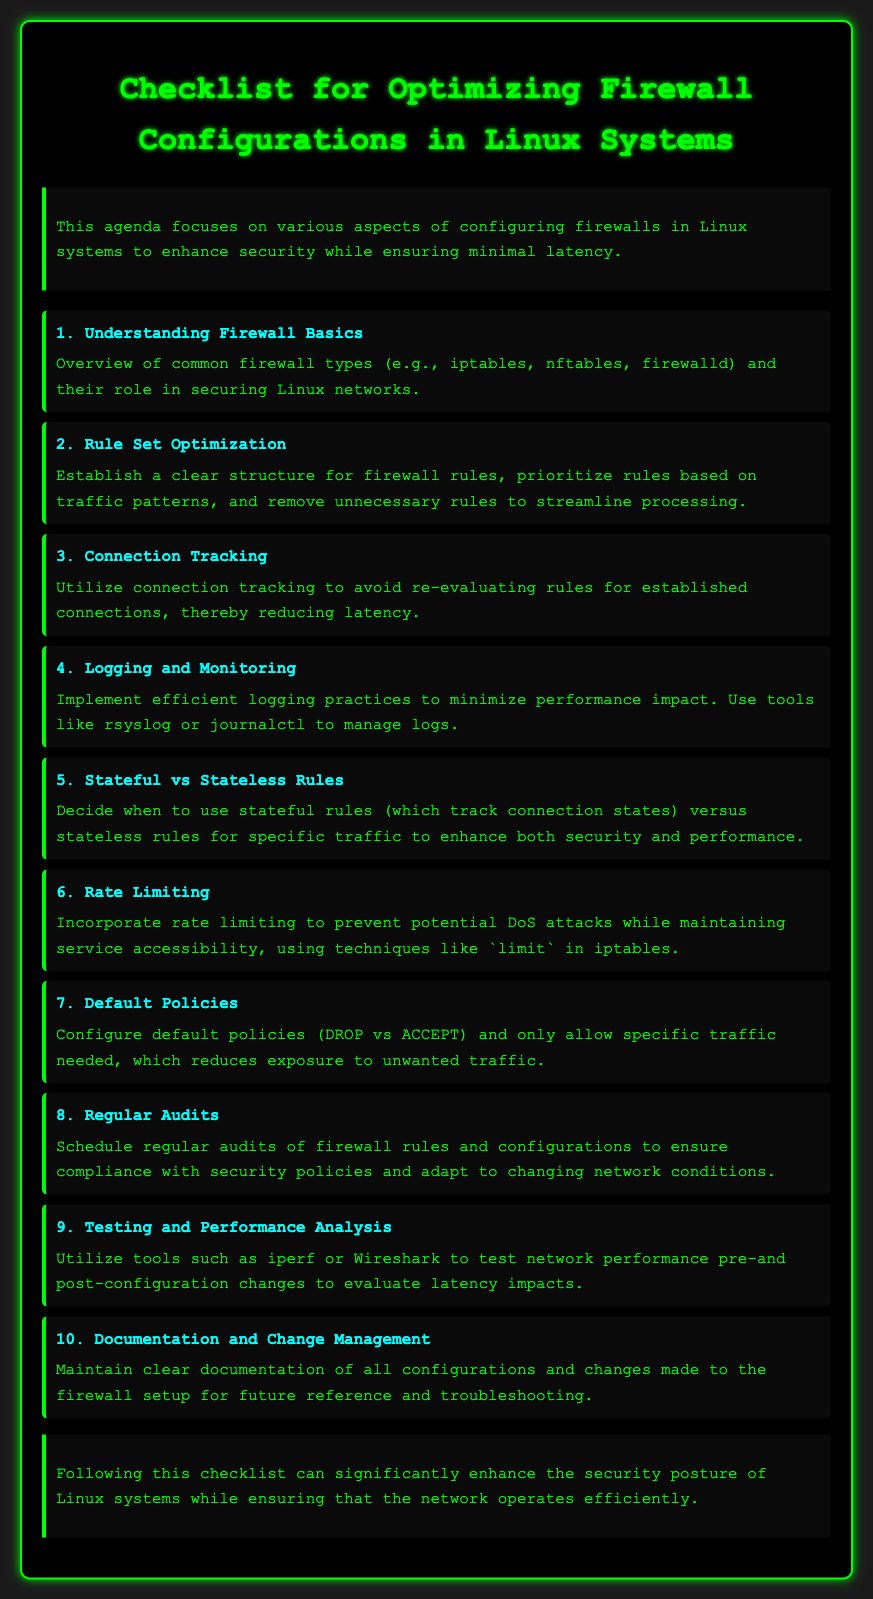What is the title of the document? The title is found in the header section of the rendered document.
Answer: Checklist for Optimizing Firewall Configurations in Linux Systems How many main topics are listed in the checklist? The main topics are numbered in the checklist section of the document.
Answer: 10 What is the primary focus of the agenda? The primary focus is outlined in the introductory paragraph of the document.
Answer: Configuring firewalls in Linux systems to enhance security while ensuring minimal latency Which tool can be used for logging according to the document? The document mentions specific tools for logging practices in the content.
Answer: rsyslog What should be incorporated to prevent DoS attacks? This is addressed in one of the main topics concerning security measures.
Answer: Rate limiting What is recommended for maintaining documentation? The document emphasizes a specific aspect of managing documentation related to firewall configurations.
Answer: Clear documentation of all configurations and changes What type of rules should be decided based on traffic? The document distinguishes between types of rules in the relevant section.
Answer: Stateful vs Stateless Rules How can network performance be tested post-configuration? The document suggests specific tools for testing performance changes in network configurations.
Answer: iperf or Wireshark 